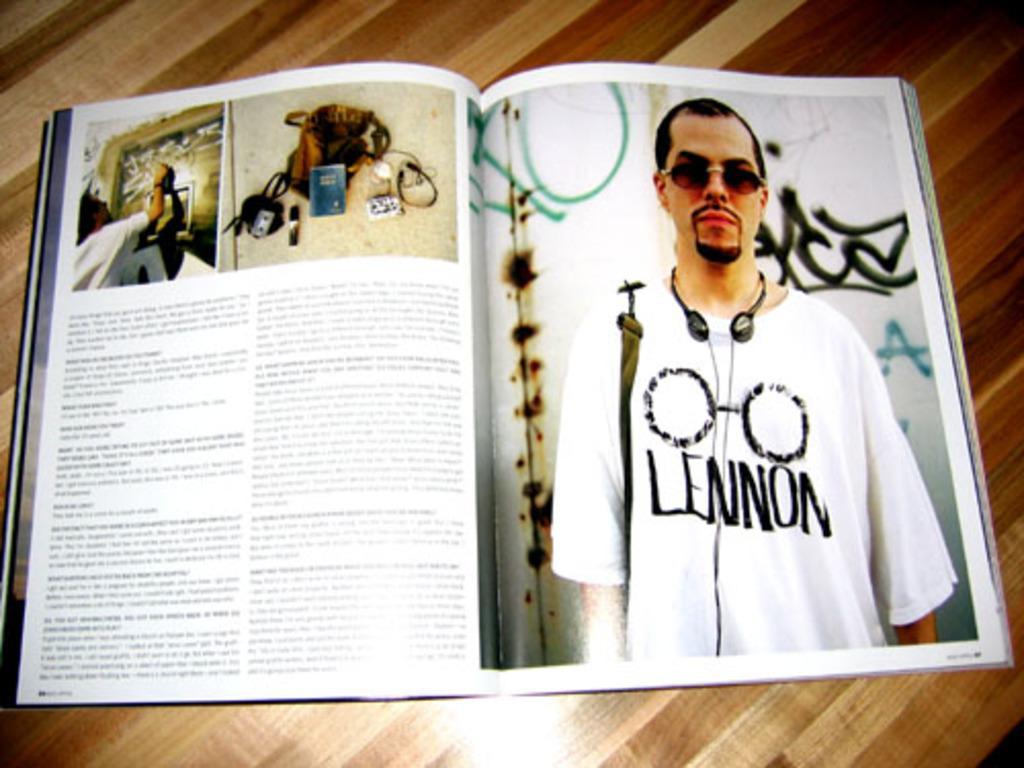Please provide a concise description of this image. On the table we can see book. On the left page there is a man, who is wearing goggles, headphone, t-shirt and bag. He is standing near to the wall. On the left page we can see bag, book, cable and other object. Here we can see another man who is doing some work. 